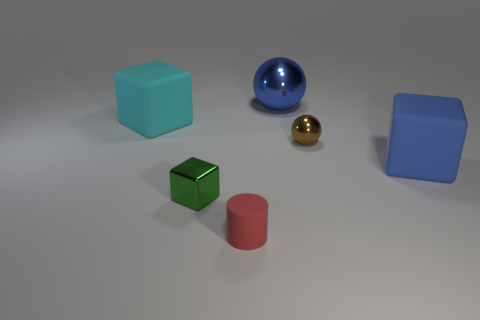Add 3 blue balls. How many objects exist? 9 Subtract all balls. How many objects are left? 4 Subtract all cyan shiny objects. Subtract all small blocks. How many objects are left? 5 Add 2 large metallic objects. How many large metallic objects are left? 3 Add 3 tiny yellow metallic balls. How many tiny yellow metallic balls exist? 3 Subtract 0 purple balls. How many objects are left? 6 